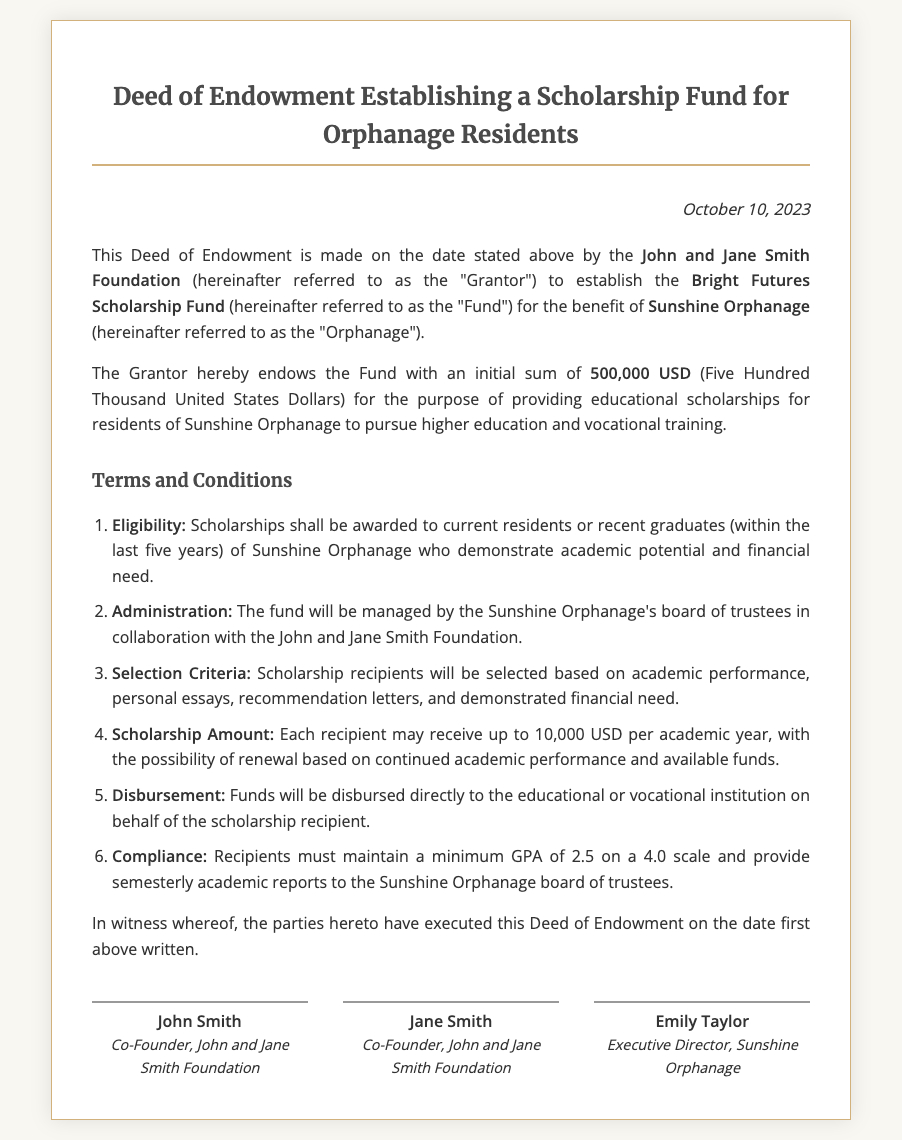What is the name of the scholarship fund? The scholarship fund is specifically named in the document.
Answer: Bright Futures Scholarship Fund Who is the Grantor of the fund? The document states the name of the organization establishing the fund.
Answer: John and Jane Smith Foundation What is the initial sum endowed to the fund? The document includes a specific monetary amount that has been endowed for the fund.
Answer: 500,000 USD What is the maximum scholarship amount per academic year? The document specifies the maximum amount that can be awarded to each recipient yearly.
Answer: 10,000 USD What GPA must recipients maintain? The document outlines a performance criterion for scholarship recipients.
Answer: 2.5 Who manages the scholarship fund? The document describes the entities responsible for overseeing the fund.
Answer: Sunshine Orphanage's board of trustees How often must recipients provide academic reports? The document states the frequency of academic reporting required from scholarship recipients.
Answer: semesterly What is the purpose of the Fund? The document explicitly mentions the goal of establishing the fund.
Answer: providing educational scholarships Who are the signatories of the deed? The document identifies three individuals who have signed the deed.
Answer: John Smith, Jane Smith, Emily Taylor 